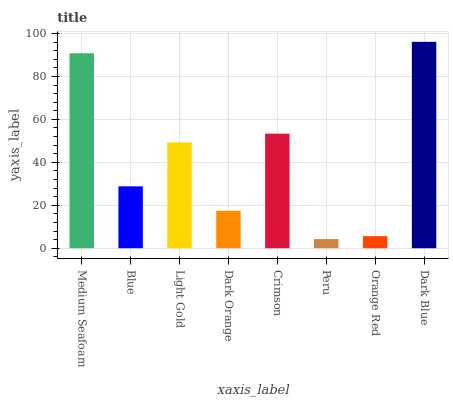Is Peru the minimum?
Answer yes or no. Yes. Is Dark Blue the maximum?
Answer yes or no. Yes. Is Blue the minimum?
Answer yes or no. No. Is Blue the maximum?
Answer yes or no. No. Is Medium Seafoam greater than Blue?
Answer yes or no. Yes. Is Blue less than Medium Seafoam?
Answer yes or no. Yes. Is Blue greater than Medium Seafoam?
Answer yes or no. No. Is Medium Seafoam less than Blue?
Answer yes or no. No. Is Light Gold the high median?
Answer yes or no. Yes. Is Blue the low median?
Answer yes or no. Yes. Is Peru the high median?
Answer yes or no. No. Is Light Gold the low median?
Answer yes or no. No. 